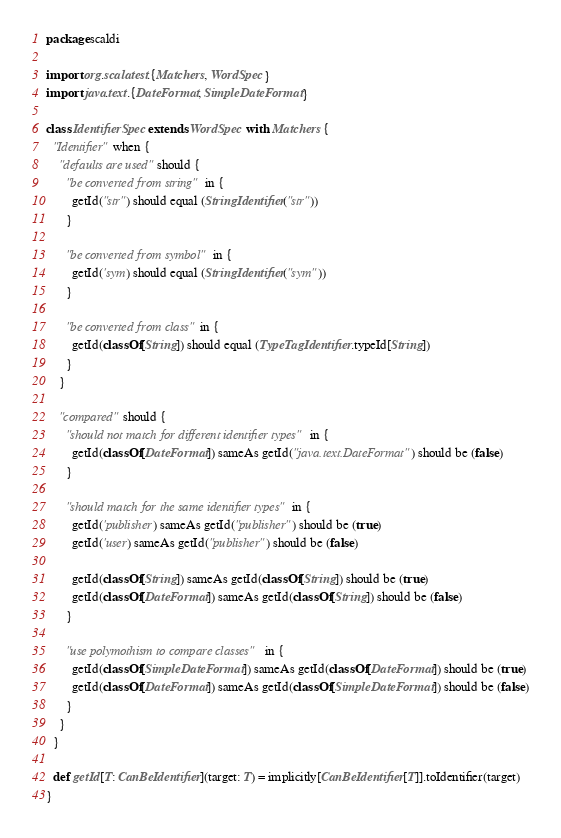Convert code to text. <code><loc_0><loc_0><loc_500><loc_500><_Scala_>package scaldi

import org.scalatest.{Matchers, WordSpec}
import java.text.{DateFormat, SimpleDateFormat}

class IdentifierSpec extends WordSpec with Matchers {
  "Identifier" when {
    "defaults are used" should {
      "be converted from string" in {
        getId("str") should equal (StringIdentifier("str"))
      }

      "be converted from symbol" in {
        getId('sym) should equal (StringIdentifier("sym"))
      }

      "be converted from class" in {
        getId(classOf[String]) should equal (TypeTagIdentifier.typeId[String])
      }
    }

    "compared" should {
      "should not match for different identifier types" in {
        getId(classOf[DateFormat]) sameAs getId("java.text.DateFormat") should be (false)
      }

      "should match for the same identifier types" in {
        getId('publisher) sameAs getId("publisher") should be (true)
        getId('user) sameAs getId("publisher") should be (false)

        getId(classOf[String]) sameAs getId(classOf[String]) should be (true)
        getId(classOf[DateFormat]) sameAs getId(classOf[String]) should be (false)
      }

      "use polymothism to compare classes" in {
        getId(classOf[SimpleDateFormat]) sameAs getId(classOf[DateFormat]) should be (true)
        getId(classOf[DateFormat]) sameAs getId(classOf[SimpleDateFormat]) should be (false)
      }
    }
  }

  def getId[T: CanBeIdentifier](target: T) = implicitly[CanBeIdentifier[T]].toIdentifier(target)
}</code> 